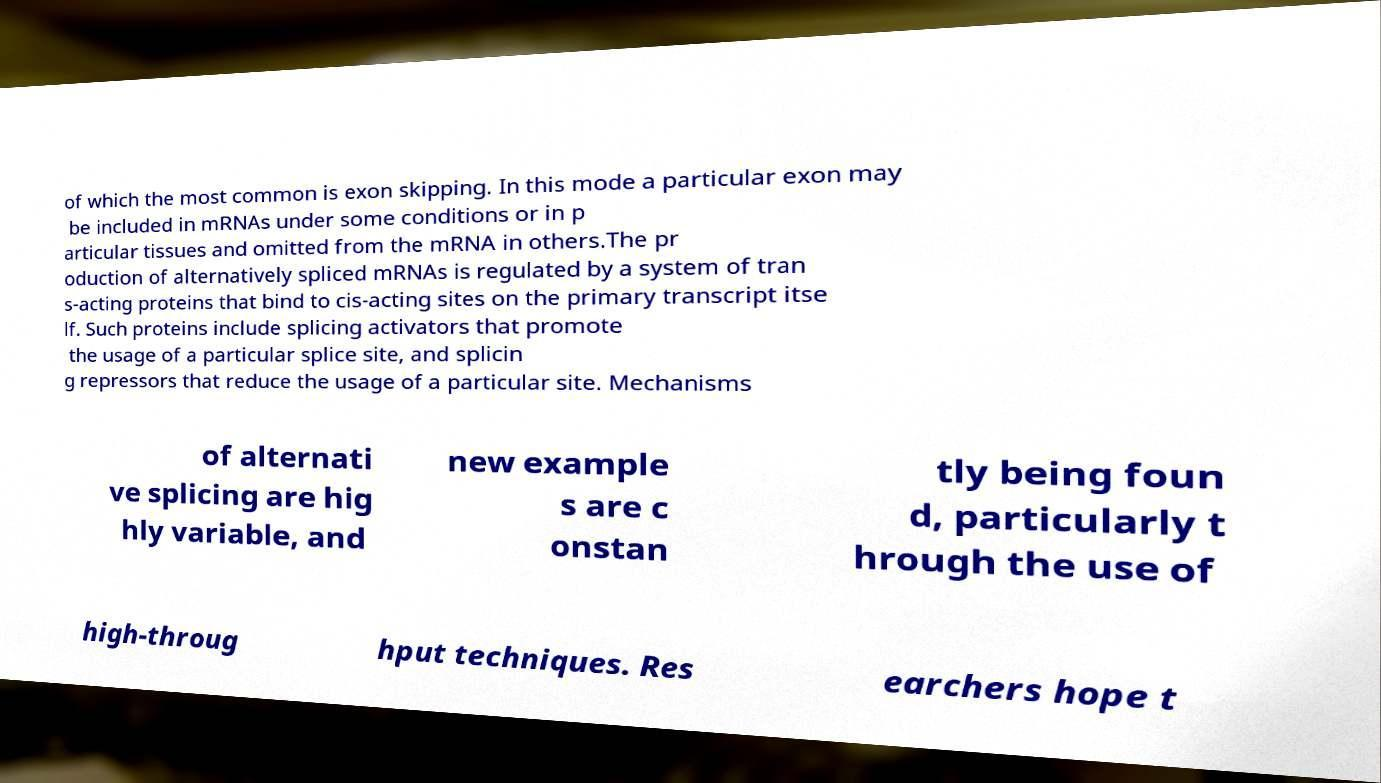I need the written content from this picture converted into text. Can you do that? of which the most common is exon skipping. In this mode a particular exon may be included in mRNAs under some conditions or in p articular tissues and omitted from the mRNA in others.The pr oduction of alternatively spliced mRNAs is regulated by a system of tran s-acting proteins that bind to cis-acting sites on the primary transcript itse lf. Such proteins include splicing activators that promote the usage of a particular splice site, and splicin g repressors that reduce the usage of a particular site. Mechanisms of alternati ve splicing are hig hly variable, and new example s are c onstan tly being foun d, particularly t hrough the use of high-throug hput techniques. Res earchers hope t 